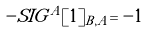<formula> <loc_0><loc_0><loc_500><loc_500>- S I G ^ { A } [ 1 ] _ { B , A } = - 1</formula> 